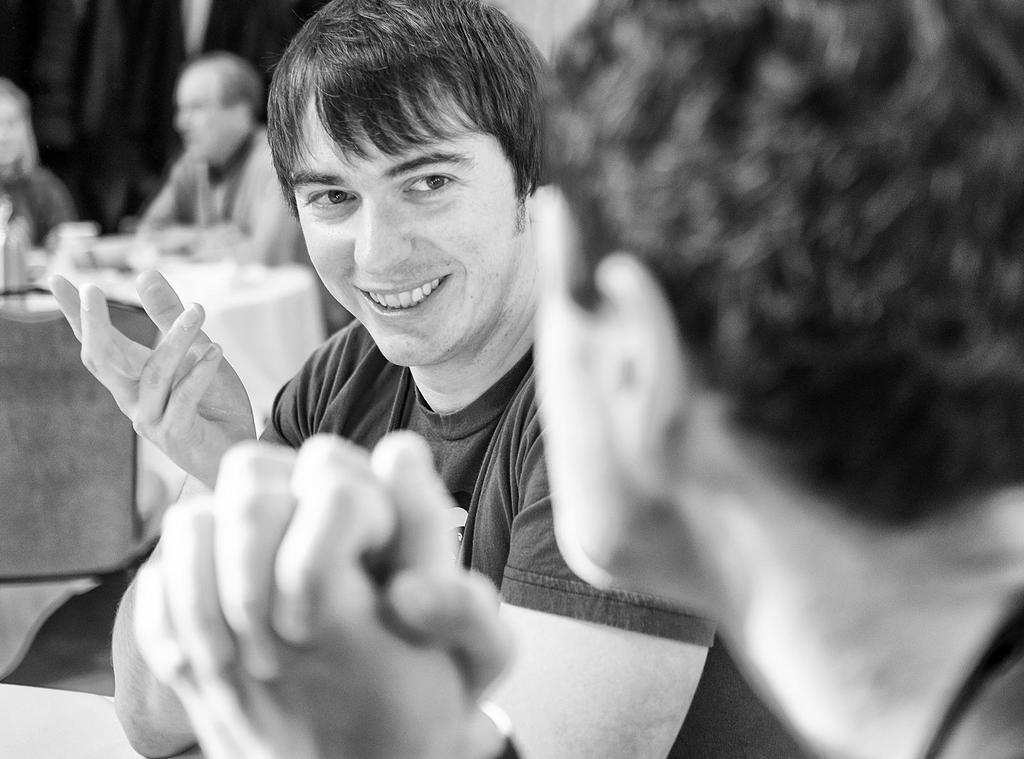What is the boy doing in the image? The boy is sitting on a chair and giving a pose into the camera. How is the boy's mood in the image? The boy is smiling in the image. What can be seen in the background of the image? There is a dining table in the image. What are the man and the woman at the dining table doing? The man and the woman are talking with each other. What time is displayed on the clock in the image? There is no clock present in the image. What type of crime is being committed in the image? There is no crime being committed in the image; it shows a boy sitting on a chair, a dining table, and a man and a woman talking. 